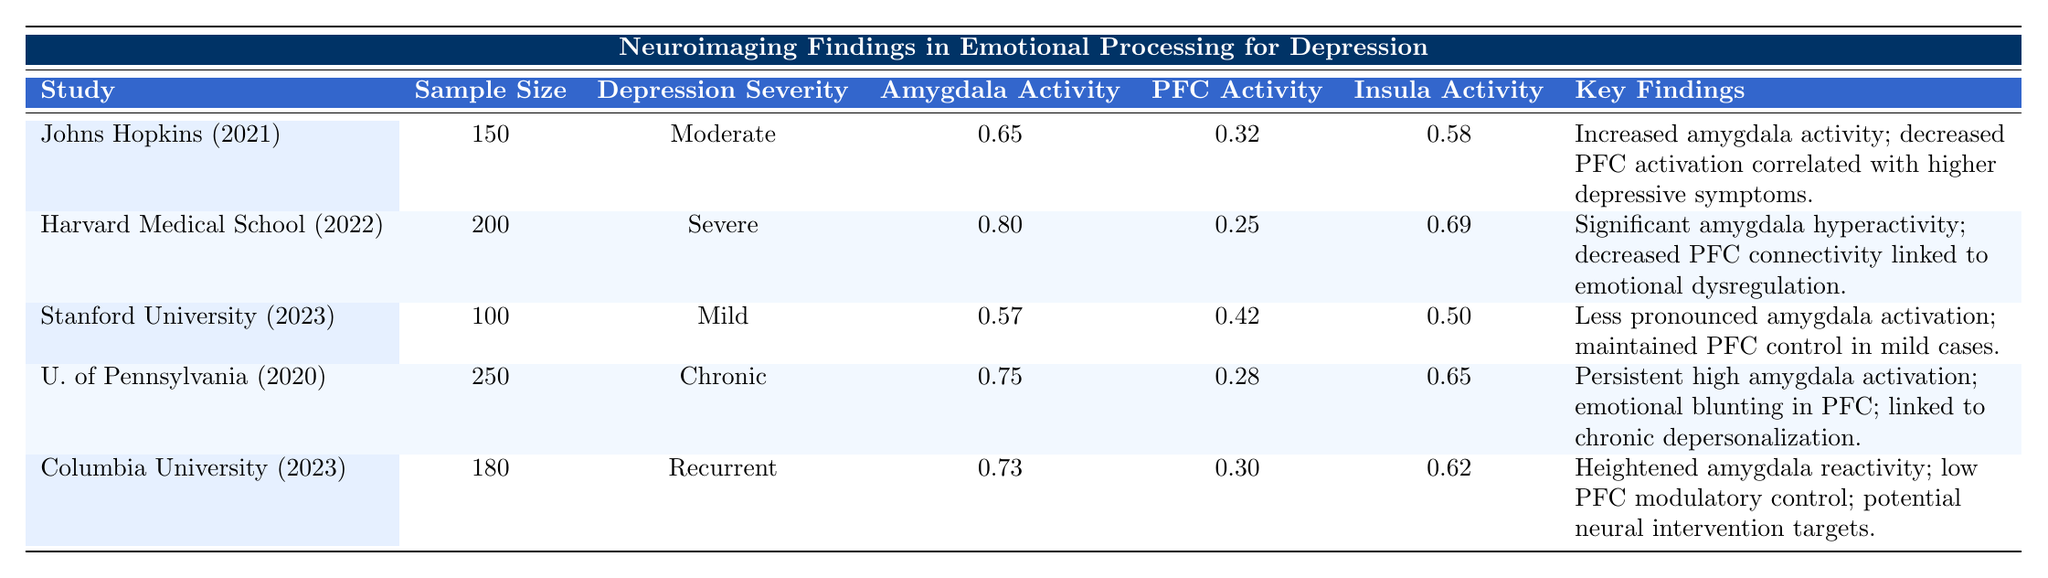What is the sample size of the study conducted by Harvard Medical School in 2022? The sample size for the Harvard Medical School study in 2022 is listed in the table under the "Sample Size" column. It shows a value of 200.
Answer: 200 Which study reported the highest amygdala activity? By examining the "Amygdala Activity" values across all studies, the highest value is found in the Harvard Medical School study (2022) with an activity level of 0.80.
Answer: 0.80 Is there a report of decreased prefrontal cortex activity associated with chronic depression? The findings from the University of Pennsylvania study indicate persistent low prefrontal cortex activity linked to high amygdala activation in chronic depression. This confirms that there is a report of decreased prefrontal cortex activity associated with chronic depression.
Answer: Yes What is the average insula activity in the studies conducted? To find the average, we sum the insula activity values: 0.58 + 0.69 + 0.50 + 0.65 + 0.62 = 3.04. There are 5 studies, so we then calculate the average: 3.04 / 5 = 0.608.
Answer: 0.608 Was there any study that indicated an increase in amygdala activity correlated with depressive symptoms? Yes, both the Johns Hopkins University study (2021) and the Harvard Medical School research (2022) indicated increased amygdala activity correlated with higher depressive symptoms.
Answer: Yes Which study had the most robust findings regarding emotional dysregulation? The Harvard Medical School study (2022) reported significant hyperactivity in the amygdala and decreased functional connectivity with the prefrontal cortex, emphasizing emotional dysregulation as a key finding.
Answer: Harvard Medical School (2022) How does the amygdala activity differ between mild and severe depression based on the studies? The study by Stanford University (2023) reported amygdala activity at 0.57 for mild depression, while the Harvard Medical School (2022) reported 0.80 for severe depression. This indicates that amygdala activity is higher in severe depression compared to mild.
Answer: Higher in severe depression What is the difference in prefrontal cortex activity between chronic and recurrent depression studies? The prefrontal cortex activity for chronic depression (University of Pennsylvania, 2020) is 0.28, while for recurrent depression (Columbia University, 2023) it is 0.30. The difference is calculated as 0.30 - 0.28 = 0.02, indicating recurrent depression had slightly higher activity.
Answer: 0.02 